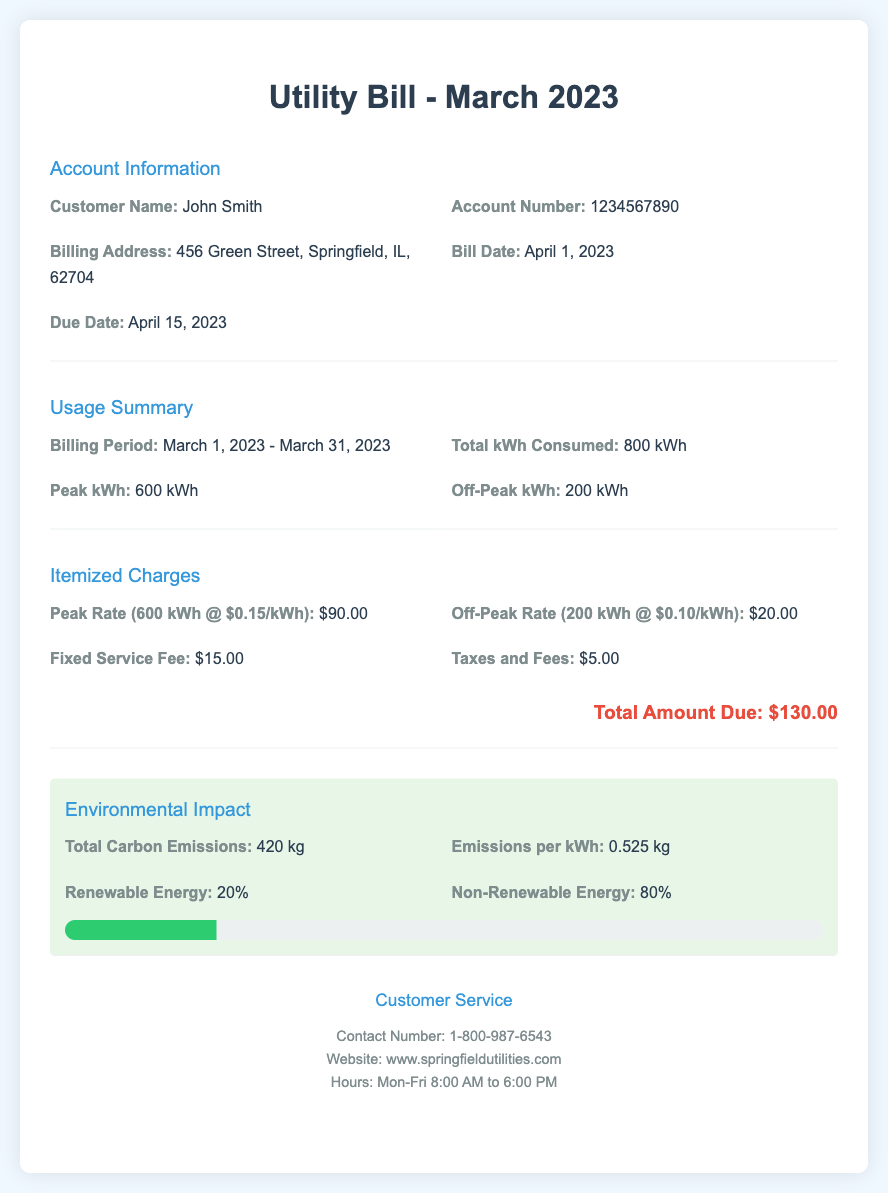what is the customer name? The customer name is provided in the account information section of the document.
Answer: John Smith what is the total kWh consumed? The total kWh consumed is shown in the usage summary section of the document.
Answer: 800 kWh what is the peak kWh? The peak kWh is specified in the usage summary section.
Answer: 600 kWh what is the total amount due? The total amount due is listed in the itemized charges section.
Answer: $130.00 how much is the fixed service fee? The fixed service fee is included in the itemized charges.
Answer: $15.00 what percentage of energy is renewable? The percentage of renewable energy is detailed in the environmental impact section.
Answer: 20% what is the due date of the bill? The due date is provided in the account information section of the document.
Answer: April 15, 2023 what is the emissions per kWh? The emissions per kWh are reported in the environmental impact section.
Answer: 0.525 kg how many kg of total carbon emissions are listed? The total carbon emissions are found in the environmental impact section of the document.
Answer: 420 kg 